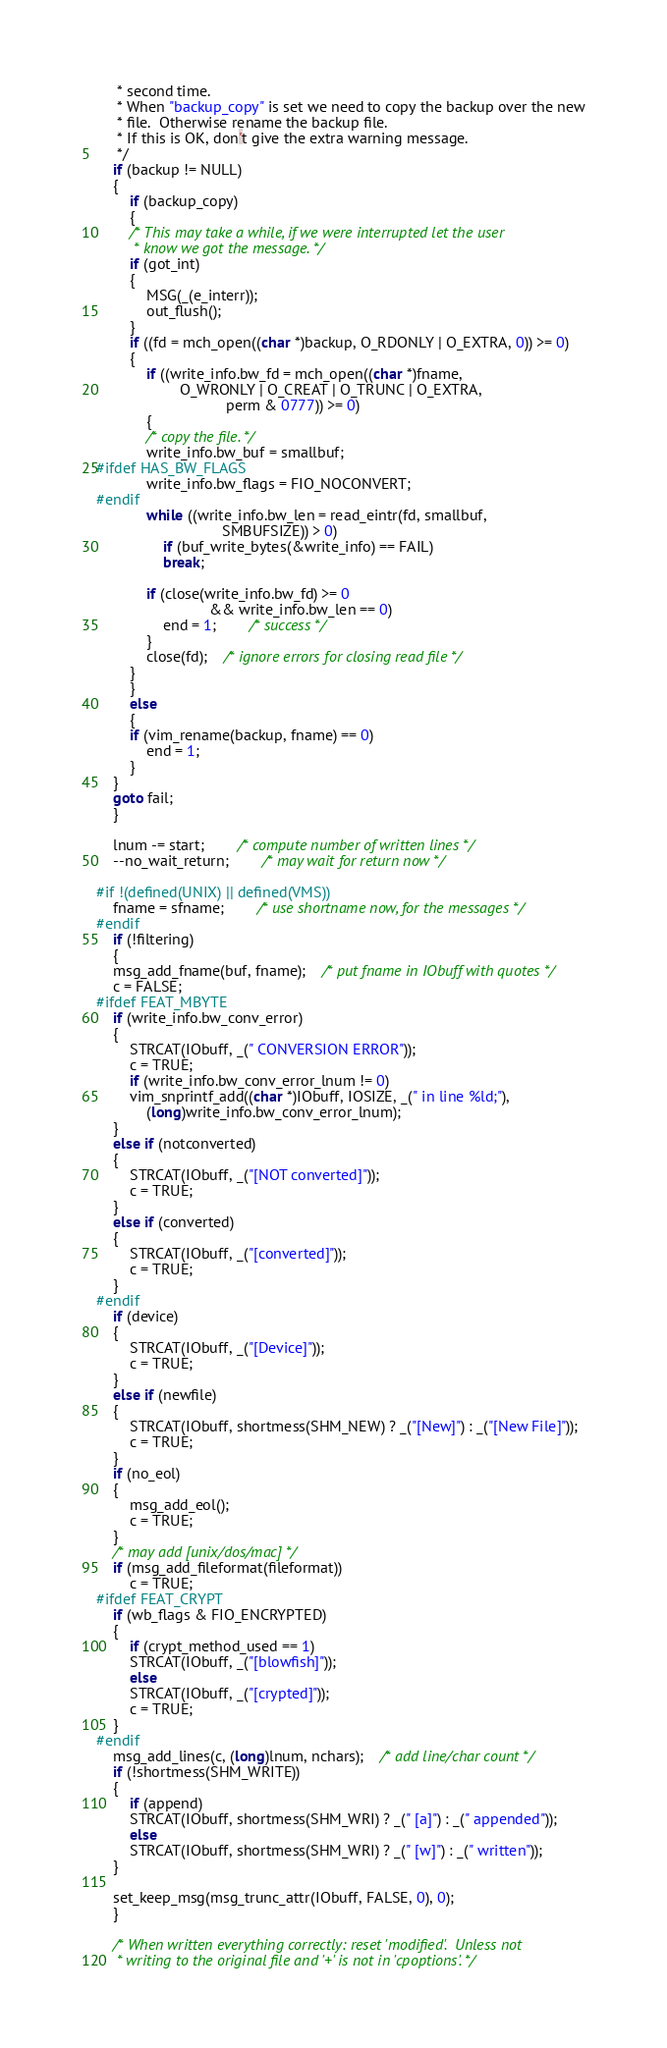Convert code to text. <code><loc_0><loc_0><loc_500><loc_500><_C_>	 * second time.
	 * When "backup_copy" is set we need to copy the backup over the new
	 * file.  Otherwise rename the backup file.
	 * If this is OK, don't give the extra warning message.
	 */
	if (backup != NULL)
	{
	    if (backup_copy)
	    {
		/* This may take a while, if we were interrupted let the user
		 * know we got the message. */
		if (got_int)
		{
		    MSG(_(e_interr));
		    out_flush();
		}
		if ((fd = mch_open((char *)backup, O_RDONLY | O_EXTRA, 0)) >= 0)
		{
		    if ((write_info.bw_fd = mch_open((char *)fname,
				    O_WRONLY | O_CREAT | O_TRUNC | O_EXTRA,
							   perm & 0777)) >= 0)
		    {
			/* copy the file. */
			write_info.bw_buf = smallbuf;
#ifdef HAS_BW_FLAGS
			write_info.bw_flags = FIO_NOCONVERT;
#endif
			while ((write_info.bw_len = read_eintr(fd, smallbuf,
						      SMBUFSIZE)) > 0)
			    if (buf_write_bytes(&write_info) == FAIL)
				break;

			if (close(write_info.bw_fd) >= 0
						   && write_info.bw_len == 0)
			    end = 1;		/* success */
		    }
		    close(fd);	/* ignore errors for closing read file */
		}
	    }
	    else
	    {
		if (vim_rename(backup, fname) == 0)
		    end = 1;
	    }
	}
	goto fail;
    }

    lnum -= start;	    /* compute number of written lines */
    --no_wait_return;	    /* may wait for return now */

#if !(defined(UNIX) || defined(VMS))
    fname = sfname;	    /* use shortname now, for the messages */
#endif
    if (!filtering)
    {
	msg_add_fname(buf, fname);	/* put fname in IObuff with quotes */
	c = FALSE;
#ifdef FEAT_MBYTE
	if (write_info.bw_conv_error)
	{
	    STRCAT(IObuff, _(" CONVERSION ERROR"));
	    c = TRUE;
	    if (write_info.bw_conv_error_lnum != 0)
		vim_snprintf_add((char *)IObuff, IOSIZE, _(" in line %ld;"),
			(long)write_info.bw_conv_error_lnum);
	}
	else if (notconverted)
	{
	    STRCAT(IObuff, _("[NOT converted]"));
	    c = TRUE;
	}
	else if (converted)
	{
	    STRCAT(IObuff, _("[converted]"));
	    c = TRUE;
	}
#endif
	if (device)
	{
	    STRCAT(IObuff, _("[Device]"));
	    c = TRUE;
	}
	else if (newfile)
	{
	    STRCAT(IObuff, shortmess(SHM_NEW) ? _("[New]") : _("[New File]"));
	    c = TRUE;
	}
	if (no_eol)
	{
	    msg_add_eol();
	    c = TRUE;
	}
	/* may add [unix/dos/mac] */
	if (msg_add_fileformat(fileformat))
	    c = TRUE;
#ifdef FEAT_CRYPT
	if (wb_flags & FIO_ENCRYPTED)
	{
	    if (crypt_method_used == 1)
		STRCAT(IObuff, _("[blowfish]"));
	    else
		STRCAT(IObuff, _("[crypted]"));
	    c = TRUE;
	}
#endif
	msg_add_lines(c, (long)lnum, nchars);	/* add line/char count */
	if (!shortmess(SHM_WRITE))
	{
	    if (append)
		STRCAT(IObuff, shortmess(SHM_WRI) ? _(" [a]") : _(" appended"));
	    else
		STRCAT(IObuff, shortmess(SHM_WRI) ? _(" [w]") : _(" written"));
	}

	set_keep_msg(msg_trunc_attr(IObuff, FALSE, 0), 0);
    }

    /* When written everything correctly: reset 'modified'.  Unless not
     * writing to the original file and '+' is not in 'cpoptions'. */</code> 